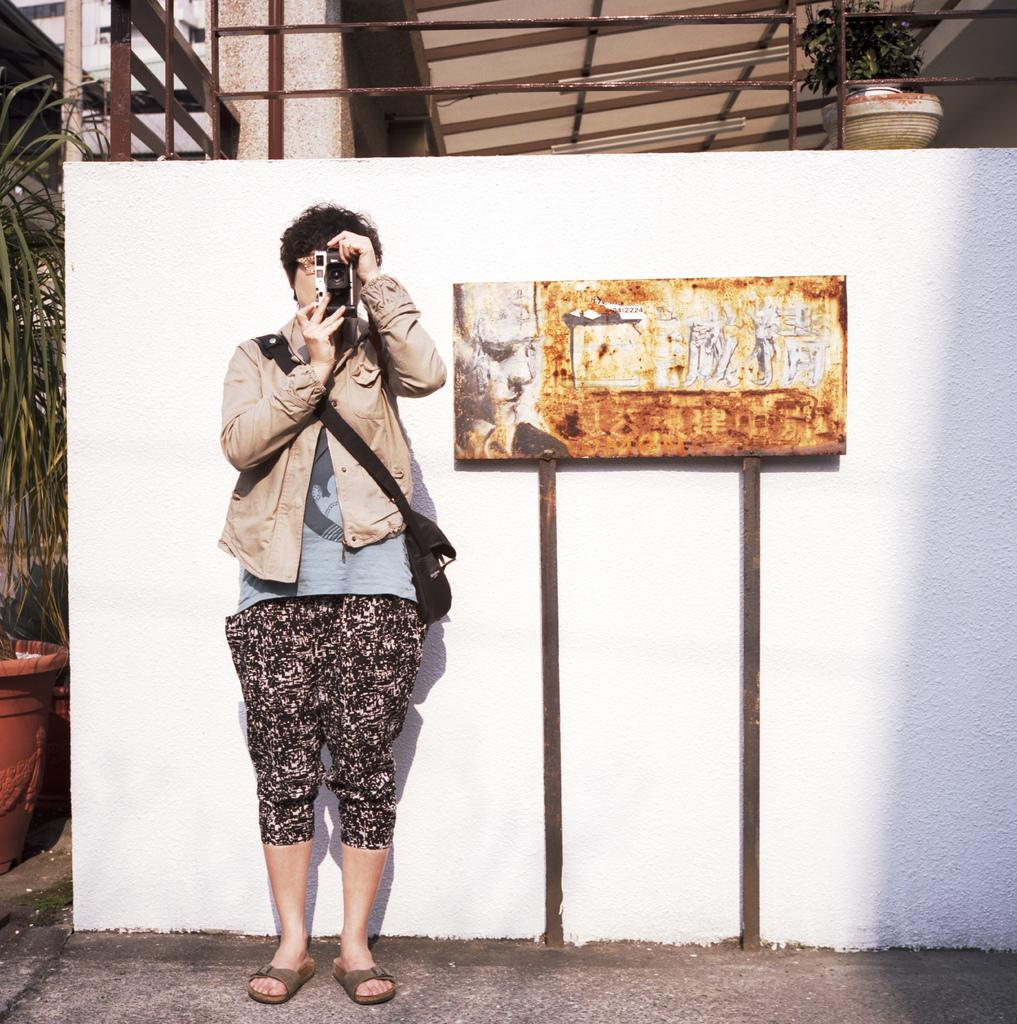What is the person in the image doing? The person in the image is standing and holding a camera. What can be seen behind the person in the image? There is a wall in the image. What is on the wall in the image? There is a board with some images in the image. What type of plants are in the image? There are potted plants in the image. What material is used for the rods in the image? There are metal rods in the image. What type of structure is visible in the image? There is a building in the image. What type of mine is visible in the image? There is no mine present in the image. How does the boundary between the building and the wall turn in the image? The image does not show any boundaries turning; it only shows a person, a wall, a board with images, potted plants, metal rods, and a building. 